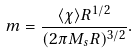Convert formula to latex. <formula><loc_0><loc_0><loc_500><loc_500>m = \frac { \langle \chi \rangle R ^ { 1 / 2 } } { ( 2 \pi M _ { s } R ) ^ { 3 / 2 } } .</formula> 